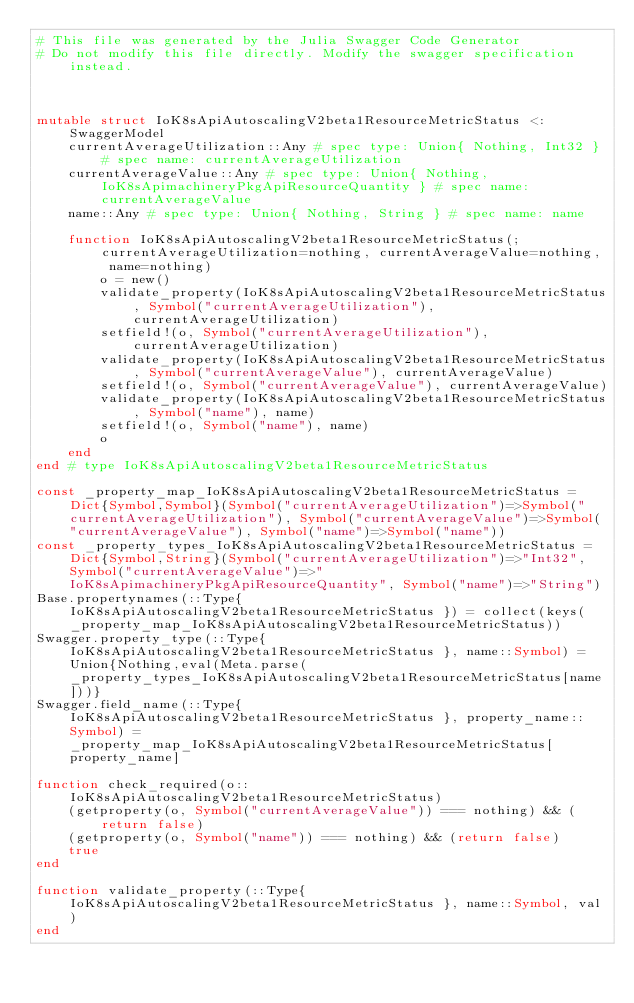<code> <loc_0><loc_0><loc_500><loc_500><_Julia_># This file was generated by the Julia Swagger Code Generator
# Do not modify this file directly. Modify the swagger specification instead.



mutable struct IoK8sApiAutoscalingV2beta1ResourceMetricStatus <: SwaggerModel
    currentAverageUtilization::Any # spec type: Union{ Nothing, Int32 } # spec name: currentAverageUtilization
    currentAverageValue::Any # spec type: Union{ Nothing, IoK8sApimachineryPkgApiResourceQuantity } # spec name: currentAverageValue
    name::Any # spec type: Union{ Nothing, String } # spec name: name

    function IoK8sApiAutoscalingV2beta1ResourceMetricStatus(;currentAverageUtilization=nothing, currentAverageValue=nothing, name=nothing)
        o = new()
        validate_property(IoK8sApiAutoscalingV2beta1ResourceMetricStatus, Symbol("currentAverageUtilization"), currentAverageUtilization)
        setfield!(o, Symbol("currentAverageUtilization"), currentAverageUtilization)
        validate_property(IoK8sApiAutoscalingV2beta1ResourceMetricStatus, Symbol("currentAverageValue"), currentAverageValue)
        setfield!(o, Symbol("currentAverageValue"), currentAverageValue)
        validate_property(IoK8sApiAutoscalingV2beta1ResourceMetricStatus, Symbol("name"), name)
        setfield!(o, Symbol("name"), name)
        o
    end
end # type IoK8sApiAutoscalingV2beta1ResourceMetricStatus

const _property_map_IoK8sApiAutoscalingV2beta1ResourceMetricStatus = Dict{Symbol,Symbol}(Symbol("currentAverageUtilization")=>Symbol("currentAverageUtilization"), Symbol("currentAverageValue")=>Symbol("currentAverageValue"), Symbol("name")=>Symbol("name"))
const _property_types_IoK8sApiAutoscalingV2beta1ResourceMetricStatus = Dict{Symbol,String}(Symbol("currentAverageUtilization")=>"Int32", Symbol("currentAverageValue")=>"IoK8sApimachineryPkgApiResourceQuantity", Symbol("name")=>"String")
Base.propertynames(::Type{ IoK8sApiAutoscalingV2beta1ResourceMetricStatus }) = collect(keys(_property_map_IoK8sApiAutoscalingV2beta1ResourceMetricStatus))
Swagger.property_type(::Type{ IoK8sApiAutoscalingV2beta1ResourceMetricStatus }, name::Symbol) = Union{Nothing,eval(Meta.parse(_property_types_IoK8sApiAutoscalingV2beta1ResourceMetricStatus[name]))}
Swagger.field_name(::Type{ IoK8sApiAutoscalingV2beta1ResourceMetricStatus }, property_name::Symbol) =  _property_map_IoK8sApiAutoscalingV2beta1ResourceMetricStatus[property_name]

function check_required(o::IoK8sApiAutoscalingV2beta1ResourceMetricStatus)
    (getproperty(o, Symbol("currentAverageValue")) === nothing) && (return false)
    (getproperty(o, Symbol("name")) === nothing) && (return false)
    true
end

function validate_property(::Type{ IoK8sApiAutoscalingV2beta1ResourceMetricStatus }, name::Symbol, val)
end
</code> 